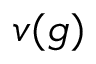Convert formula to latex. <formula><loc_0><loc_0><loc_500><loc_500>v ( g )</formula> 